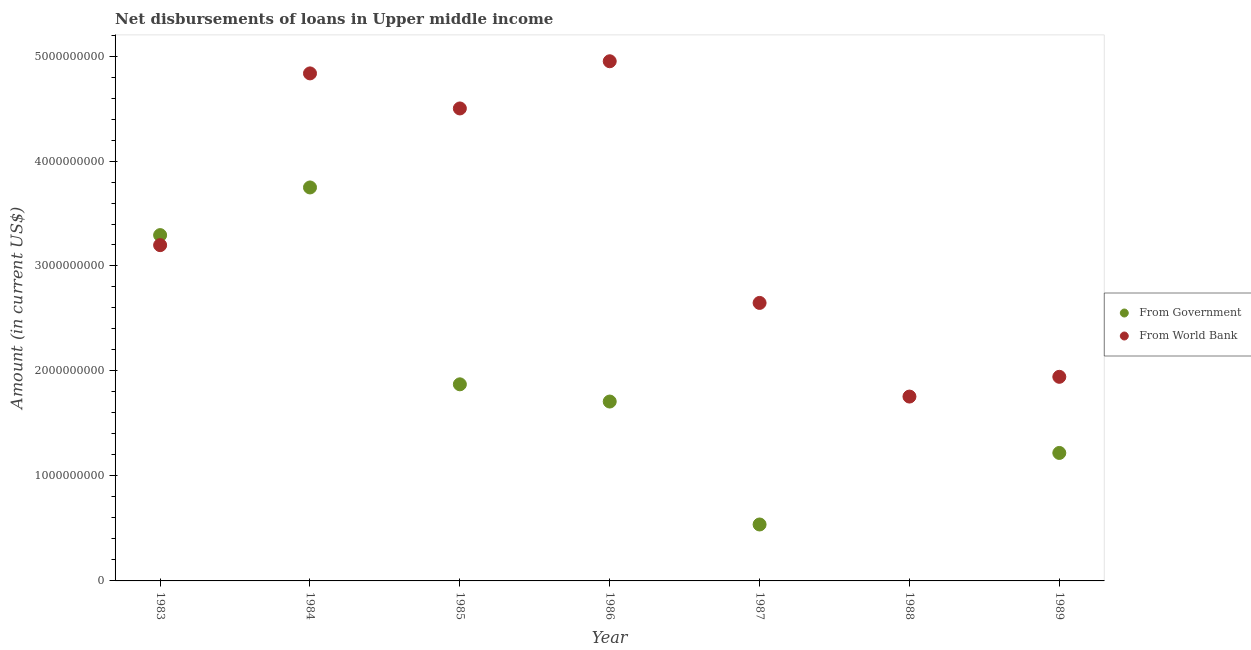What is the net disbursements of loan from world bank in 1983?
Your answer should be very brief. 3.20e+09. Across all years, what is the maximum net disbursements of loan from government?
Your response must be concise. 3.75e+09. Across all years, what is the minimum net disbursements of loan from government?
Your response must be concise. 0. What is the total net disbursements of loan from government in the graph?
Your response must be concise. 1.24e+1. What is the difference between the net disbursements of loan from world bank in 1984 and that in 1986?
Ensure brevity in your answer.  -1.16e+08. What is the difference between the net disbursements of loan from government in 1986 and the net disbursements of loan from world bank in 1984?
Ensure brevity in your answer.  -3.13e+09. What is the average net disbursements of loan from world bank per year?
Keep it short and to the point. 3.40e+09. In the year 1989, what is the difference between the net disbursements of loan from government and net disbursements of loan from world bank?
Keep it short and to the point. -7.25e+08. What is the ratio of the net disbursements of loan from government in 1983 to that in 1987?
Ensure brevity in your answer.  6.13. Is the net disbursements of loan from world bank in 1984 less than that in 1988?
Make the answer very short. No. What is the difference between the highest and the second highest net disbursements of loan from world bank?
Offer a terse response. 1.16e+08. What is the difference between the highest and the lowest net disbursements of loan from world bank?
Your answer should be very brief. 3.19e+09. In how many years, is the net disbursements of loan from world bank greater than the average net disbursements of loan from world bank taken over all years?
Your response must be concise. 3. Is the net disbursements of loan from government strictly less than the net disbursements of loan from world bank over the years?
Ensure brevity in your answer.  No. How many years are there in the graph?
Your response must be concise. 7. Where does the legend appear in the graph?
Keep it short and to the point. Center right. How many legend labels are there?
Give a very brief answer. 2. How are the legend labels stacked?
Keep it short and to the point. Vertical. What is the title of the graph?
Offer a very short reply. Net disbursements of loans in Upper middle income. Does "US$" appear as one of the legend labels in the graph?
Make the answer very short. No. What is the Amount (in current US$) in From Government in 1983?
Your answer should be very brief. 3.29e+09. What is the Amount (in current US$) of From World Bank in 1983?
Give a very brief answer. 3.20e+09. What is the Amount (in current US$) of From Government in 1984?
Keep it short and to the point. 3.75e+09. What is the Amount (in current US$) in From World Bank in 1984?
Keep it short and to the point. 4.83e+09. What is the Amount (in current US$) of From Government in 1985?
Ensure brevity in your answer.  1.87e+09. What is the Amount (in current US$) in From World Bank in 1985?
Your answer should be very brief. 4.50e+09. What is the Amount (in current US$) of From Government in 1986?
Your answer should be compact. 1.71e+09. What is the Amount (in current US$) in From World Bank in 1986?
Keep it short and to the point. 4.95e+09. What is the Amount (in current US$) of From Government in 1987?
Keep it short and to the point. 5.38e+08. What is the Amount (in current US$) of From World Bank in 1987?
Ensure brevity in your answer.  2.65e+09. What is the Amount (in current US$) in From World Bank in 1988?
Provide a succinct answer. 1.76e+09. What is the Amount (in current US$) of From Government in 1989?
Offer a very short reply. 1.22e+09. What is the Amount (in current US$) in From World Bank in 1989?
Provide a short and direct response. 1.94e+09. Across all years, what is the maximum Amount (in current US$) of From Government?
Provide a short and direct response. 3.75e+09. Across all years, what is the maximum Amount (in current US$) of From World Bank?
Make the answer very short. 4.95e+09. Across all years, what is the minimum Amount (in current US$) in From Government?
Provide a succinct answer. 0. Across all years, what is the minimum Amount (in current US$) of From World Bank?
Make the answer very short. 1.76e+09. What is the total Amount (in current US$) of From Government in the graph?
Ensure brevity in your answer.  1.24e+1. What is the total Amount (in current US$) in From World Bank in the graph?
Provide a short and direct response. 2.38e+1. What is the difference between the Amount (in current US$) in From Government in 1983 and that in 1984?
Provide a short and direct response. -4.54e+08. What is the difference between the Amount (in current US$) in From World Bank in 1983 and that in 1984?
Ensure brevity in your answer.  -1.64e+09. What is the difference between the Amount (in current US$) of From Government in 1983 and that in 1985?
Your answer should be compact. 1.42e+09. What is the difference between the Amount (in current US$) of From World Bank in 1983 and that in 1985?
Your answer should be very brief. -1.30e+09. What is the difference between the Amount (in current US$) in From Government in 1983 and that in 1986?
Offer a terse response. 1.59e+09. What is the difference between the Amount (in current US$) of From World Bank in 1983 and that in 1986?
Ensure brevity in your answer.  -1.75e+09. What is the difference between the Amount (in current US$) in From Government in 1983 and that in 1987?
Your answer should be compact. 2.76e+09. What is the difference between the Amount (in current US$) in From World Bank in 1983 and that in 1987?
Keep it short and to the point. 5.50e+08. What is the difference between the Amount (in current US$) in From World Bank in 1983 and that in 1988?
Provide a short and direct response. 1.44e+09. What is the difference between the Amount (in current US$) of From Government in 1983 and that in 1989?
Ensure brevity in your answer.  2.08e+09. What is the difference between the Amount (in current US$) of From World Bank in 1983 and that in 1989?
Make the answer very short. 1.25e+09. What is the difference between the Amount (in current US$) of From Government in 1984 and that in 1985?
Make the answer very short. 1.88e+09. What is the difference between the Amount (in current US$) in From World Bank in 1984 and that in 1985?
Ensure brevity in your answer.  3.34e+08. What is the difference between the Amount (in current US$) in From Government in 1984 and that in 1986?
Give a very brief answer. 2.04e+09. What is the difference between the Amount (in current US$) of From World Bank in 1984 and that in 1986?
Keep it short and to the point. -1.16e+08. What is the difference between the Amount (in current US$) of From Government in 1984 and that in 1987?
Offer a very short reply. 3.21e+09. What is the difference between the Amount (in current US$) of From World Bank in 1984 and that in 1987?
Your response must be concise. 2.19e+09. What is the difference between the Amount (in current US$) of From World Bank in 1984 and that in 1988?
Offer a very short reply. 3.08e+09. What is the difference between the Amount (in current US$) in From Government in 1984 and that in 1989?
Your answer should be compact. 2.53e+09. What is the difference between the Amount (in current US$) of From World Bank in 1984 and that in 1989?
Your response must be concise. 2.89e+09. What is the difference between the Amount (in current US$) of From Government in 1985 and that in 1986?
Make the answer very short. 1.64e+08. What is the difference between the Amount (in current US$) in From World Bank in 1985 and that in 1986?
Provide a short and direct response. -4.50e+08. What is the difference between the Amount (in current US$) in From Government in 1985 and that in 1987?
Make the answer very short. 1.34e+09. What is the difference between the Amount (in current US$) in From World Bank in 1985 and that in 1987?
Ensure brevity in your answer.  1.85e+09. What is the difference between the Amount (in current US$) of From World Bank in 1985 and that in 1988?
Give a very brief answer. 2.74e+09. What is the difference between the Amount (in current US$) in From Government in 1985 and that in 1989?
Offer a terse response. 6.54e+08. What is the difference between the Amount (in current US$) of From World Bank in 1985 and that in 1989?
Make the answer very short. 2.56e+09. What is the difference between the Amount (in current US$) in From Government in 1986 and that in 1987?
Keep it short and to the point. 1.17e+09. What is the difference between the Amount (in current US$) in From World Bank in 1986 and that in 1987?
Provide a succinct answer. 2.30e+09. What is the difference between the Amount (in current US$) in From World Bank in 1986 and that in 1988?
Your answer should be very brief. 3.19e+09. What is the difference between the Amount (in current US$) of From Government in 1986 and that in 1989?
Ensure brevity in your answer.  4.90e+08. What is the difference between the Amount (in current US$) of From World Bank in 1986 and that in 1989?
Give a very brief answer. 3.01e+09. What is the difference between the Amount (in current US$) of From World Bank in 1987 and that in 1988?
Give a very brief answer. 8.92e+08. What is the difference between the Amount (in current US$) of From Government in 1987 and that in 1989?
Provide a short and direct response. -6.81e+08. What is the difference between the Amount (in current US$) in From World Bank in 1987 and that in 1989?
Provide a succinct answer. 7.04e+08. What is the difference between the Amount (in current US$) of From World Bank in 1988 and that in 1989?
Give a very brief answer. -1.88e+08. What is the difference between the Amount (in current US$) of From Government in 1983 and the Amount (in current US$) of From World Bank in 1984?
Keep it short and to the point. -1.54e+09. What is the difference between the Amount (in current US$) of From Government in 1983 and the Amount (in current US$) of From World Bank in 1985?
Make the answer very short. -1.21e+09. What is the difference between the Amount (in current US$) of From Government in 1983 and the Amount (in current US$) of From World Bank in 1986?
Keep it short and to the point. -1.66e+09. What is the difference between the Amount (in current US$) of From Government in 1983 and the Amount (in current US$) of From World Bank in 1987?
Offer a very short reply. 6.46e+08. What is the difference between the Amount (in current US$) in From Government in 1983 and the Amount (in current US$) in From World Bank in 1988?
Keep it short and to the point. 1.54e+09. What is the difference between the Amount (in current US$) in From Government in 1983 and the Amount (in current US$) in From World Bank in 1989?
Make the answer very short. 1.35e+09. What is the difference between the Amount (in current US$) in From Government in 1984 and the Amount (in current US$) in From World Bank in 1985?
Your response must be concise. -7.53e+08. What is the difference between the Amount (in current US$) in From Government in 1984 and the Amount (in current US$) in From World Bank in 1986?
Ensure brevity in your answer.  -1.20e+09. What is the difference between the Amount (in current US$) in From Government in 1984 and the Amount (in current US$) in From World Bank in 1987?
Your answer should be very brief. 1.10e+09. What is the difference between the Amount (in current US$) of From Government in 1984 and the Amount (in current US$) of From World Bank in 1988?
Make the answer very short. 1.99e+09. What is the difference between the Amount (in current US$) of From Government in 1984 and the Amount (in current US$) of From World Bank in 1989?
Make the answer very short. 1.80e+09. What is the difference between the Amount (in current US$) in From Government in 1985 and the Amount (in current US$) in From World Bank in 1986?
Provide a succinct answer. -3.08e+09. What is the difference between the Amount (in current US$) in From Government in 1985 and the Amount (in current US$) in From World Bank in 1987?
Offer a very short reply. -7.75e+08. What is the difference between the Amount (in current US$) in From Government in 1985 and the Amount (in current US$) in From World Bank in 1988?
Your response must be concise. 1.17e+08. What is the difference between the Amount (in current US$) of From Government in 1985 and the Amount (in current US$) of From World Bank in 1989?
Your answer should be very brief. -7.15e+07. What is the difference between the Amount (in current US$) of From Government in 1986 and the Amount (in current US$) of From World Bank in 1987?
Provide a short and direct response. -9.39e+08. What is the difference between the Amount (in current US$) of From Government in 1986 and the Amount (in current US$) of From World Bank in 1988?
Ensure brevity in your answer.  -4.74e+07. What is the difference between the Amount (in current US$) of From Government in 1986 and the Amount (in current US$) of From World Bank in 1989?
Give a very brief answer. -2.36e+08. What is the difference between the Amount (in current US$) in From Government in 1987 and the Amount (in current US$) in From World Bank in 1988?
Your answer should be very brief. -1.22e+09. What is the difference between the Amount (in current US$) of From Government in 1987 and the Amount (in current US$) of From World Bank in 1989?
Provide a short and direct response. -1.41e+09. What is the average Amount (in current US$) of From Government per year?
Give a very brief answer. 1.77e+09. What is the average Amount (in current US$) of From World Bank per year?
Your answer should be compact. 3.40e+09. In the year 1983, what is the difference between the Amount (in current US$) in From Government and Amount (in current US$) in From World Bank?
Keep it short and to the point. 9.56e+07. In the year 1984, what is the difference between the Amount (in current US$) of From Government and Amount (in current US$) of From World Bank?
Keep it short and to the point. -1.09e+09. In the year 1985, what is the difference between the Amount (in current US$) of From Government and Amount (in current US$) of From World Bank?
Provide a short and direct response. -2.63e+09. In the year 1986, what is the difference between the Amount (in current US$) of From Government and Amount (in current US$) of From World Bank?
Your answer should be very brief. -3.24e+09. In the year 1987, what is the difference between the Amount (in current US$) in From Government and Amount (in current US$) in From World Bank?
Keep it short and to the point. -2.11e+09. In the year 1989, what is the difference between the Amount (in current US$) in From Government and Amount (in current US$) in From World Bank?
Offer a terse response. -7.25e+08. What is the ratio of the Amount (in current US$) in From Government in 1983 to that in 1984?
Your answer should be compact. 0.88. What is the ratio of the Amount (in current US$) in From World Bank in 1983 to that in 1984?
Give a very brief answer. 0.66. What is the ratio of the Amount (in current US$) of From Government in 1983 to that in 1985?
Provide a succinct answer. 1.76. What is the ratio of the Amount (in current US$) of From World Bank in 1983 to that in 1985?
Offer a terse response. 0.71. What is the ratio of the Amount (in current US$) of From Government in 1983 to that in 1986?
Offer a very short reply. 1.93. What is the ratio of the Amount (in current US$) in From World Bank in 1983 to that in 1986?
Offer a terse response. 0.65. What is the ratio of the Amount (in current US$) in From Government in 1983 to that in 1987?
Make the answer very short. 6.13. What is the ratio of the Amount (in current US$) of From World Bank in 1983 to that in 1987?
Your answer should be very brief. 1.21. What is the ratio of the Amount (in current US$) in From World Bank in 1983 to that in 1988?
Provide a succinct answer. 1.82. What is the ratio of the Amount (in current US$) of From Government in 1983 to that in 1989?
Provide a succinct answer. 2.7. What is the ratio of the Amount (in current US$) of From World Bank in 1983 to that in 1989?
Provide a short and direct response. 1.65. What is the ratio of the Amount (in current US$) of From Government in 1984 to that in 1985?
Your response must be concise. 2. What is the ratio of the Amount (in current US$) in From World Bank in 1984 to that in 1985?
Your answer should be compact. 1.07. What is the ratio of the Amount (in current US$) in From Government in 1984 to that in 1986?
Your answer should be very brief. 2.19. What is the ratio of the Amount (in current US$) of From World Bank in 1984 to that in 1986?
Keep it short and to the point. 0.98. What is the ratio of the Amount (in current US$) of From Government in 1984 to that in 1987?
Provide a short and direct response. 6.97. What is the ratio of the Amount (in current US$) in From World Bank in 1984 to that in 1987?
Ensure brevity in your answer.  1.83. What is the ratio of the Amount (in current US$) of From World Bank in 1984 to that in 1988?
Provide a short and direct response. 2.75. What is the ratio of the Amount (in current US$) of From Government in 1984 to that in 1989?
Offer a very short reply. 3.07. What is the ratio of the Amount (in current US$) of From World Bank in 1984 to that in 1989?
Provide a succinct answer. 2.49. What is the ratio of the Amount (in current US$) in From Government in 1985 to that in 1986?
Make the answer very short. 1.1. What is the ratio of the Amount (in current US$) of From World Bank in 1985 to that in 1986?
Keep it short and to the point. 0.91. What is the ratio of the Amount (in current US$) of From Government in 1985 to that in 1987?
Offer a terse response. 3.48. What is the ratio of the Amount (in current US$) of From World Bank in 1985 to that in 1987?
Make the answer very short. 1.7. What is the ratio of the Amount (in current US$) of From World Bank in 1985 to that in 1988?
Give a very brief answer. 2.56. What is the ratio of the Amount (in current US$) of From Government in 1985 to that in 1989?
Offer a terse response. 1.54. What is the ratio of the Amount (in current US$) in From World Bank in 1985 to that in 1989?
Ensure brevity in your answer.  2.31. What is the ratio of the Amount (in current US$) in From Government in 1986 to that in 1987?
Your answer should be very brief. 3.18. What is the ratio of the Amount (in current US$) in From World Bank in 1986 to that in 1987?
Keep it short and to the point. 1.87. What is the ratio of the Amount (in current US$) of From World Bank in 1986 to that in 1988?
Ensure brevity in your answer.  2.82. What is the ratio of the Amount (in current US$) of From Government in 1986 to that in 1989?
Your response must be concise. 1.4. What is the ratio of the Amount (in current US$) of From World Bank in 1986 to that in 1989?
Give a very brief answer. 2.55. What is the ratio of the Amount (in current US$) in From World Bank in 1987 to that in 1988?
Offer a very short reply. 1.51. What is the ratio of the Amount (in current US$) of From Government in 1987 to that in 1989?
Provide a succinct answer. 0.44. What is the ratio of the Amount (in current US$) in From World Bank in 1987 to that in 1989?
Ensure brevity in your answer.  1.36. What is the ratio of the Amount (in current US$) of From World Bank in 1988 to that in 1989?
Give a very brief answer. 0.9. What is the difference between the highest and the second highest Amount (in current US$) of From Government?
Make the answer very short. 4.54e+08. What is the difference between the highest and the second highest Amount (in current US$) in From World Bank?
Your answer should be very brief. 1.16e+08. What is the difference between the highest and the lowest Amount (in current US$) in From Government?
Your answer should be compact. 3.75e+09. What is the difference between the highest and the lowest Amount (in current US$) in From World Bank?
Offer a terse response. 3.19e+09. 